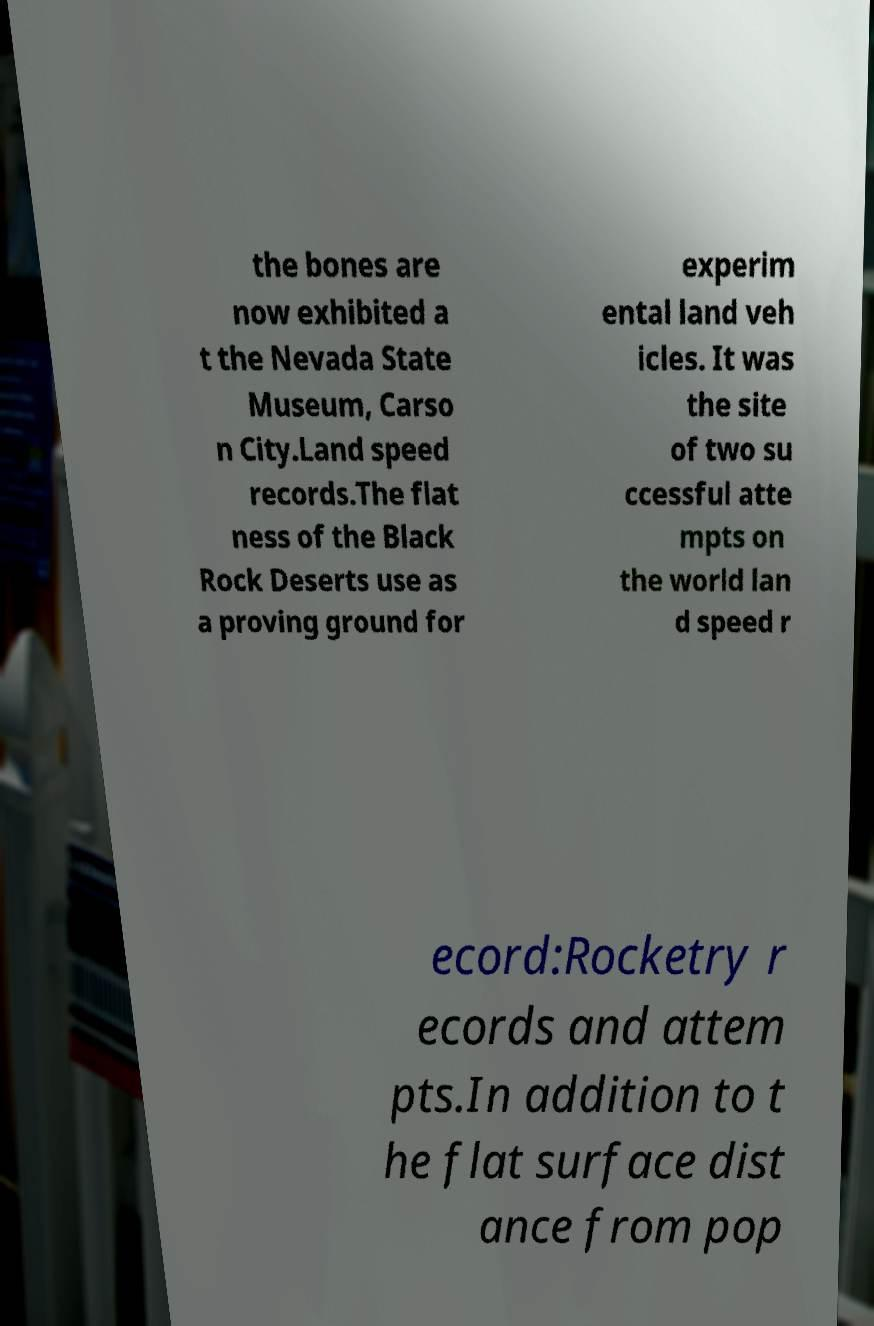Could you assist in decoding the text presented in this image and type it out clearly? the bones are now exhibited a t the Nevada State Museum, Carso n City.Land speed records.The flat ness of the Black Rock Deserts use as a proving ground for experim ental land veh icles. It was the site of two su ccessful atte mpts on the world lan d speed r ecord:Rocketry r ecords and attem pts.In addition to t he flat surface dist ance from pop 